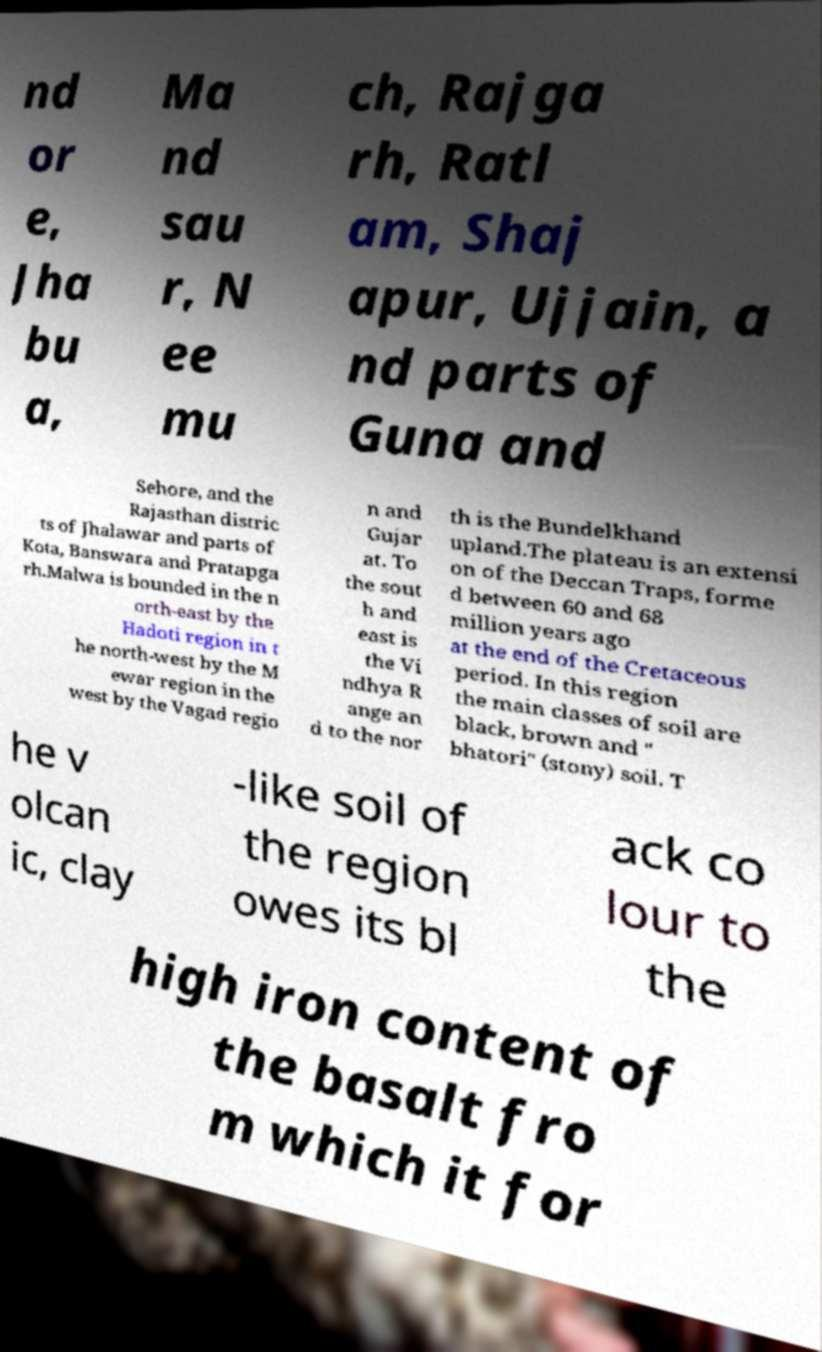Could you extract and type out the text from this image? nd or e, Jha bu a, Ma nd sau r, N ee mu ch, Rajga rh, Ratl am, Shaj apur, Ujjain, a nd parts of Guna and Sehore, and the Rajasthan distric ts of Jhalawar and parts of Kota, Banswara and Pratapga rh.Malwa is bounded in the n orth-east by the Hadoti region in t he north-west by the M ewar region in the west by the Vagad regio n and Gujar at. To the sout h and east is the Vi ndhya R ange an d to the nor th is the Bundelkhand upland.The plateau is an extensi on of the Deccan Traps, forme d between 60 and 68 million years ago at the end of the Cretaceous period. In this region the main classes of soil are black, brown and " bhatori" (stony) soil. T he v olcan ic, clay -like soil of the region owes its bl ack co lour to the high iron content of the basalt fro m which it for 